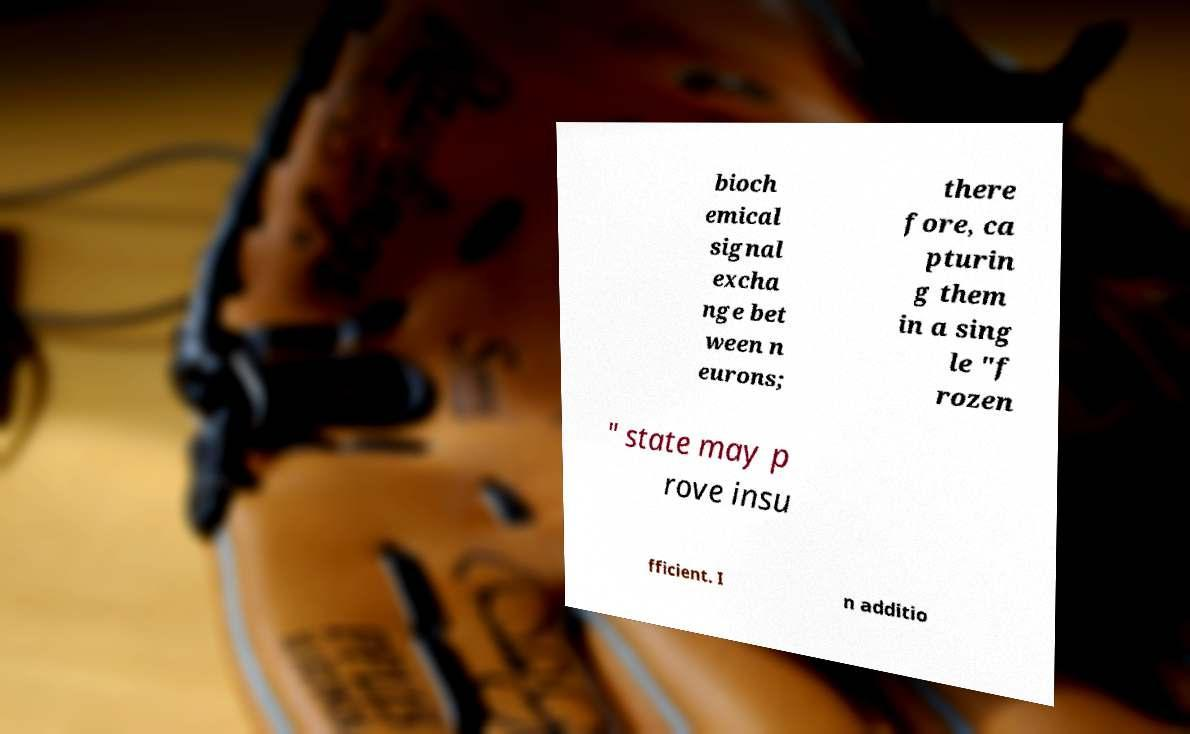Can you read and provide the text displayed in the image?This photo seems to have some interesting text. Can you extract and type it out for me? bioch emical signal excha nge bet ween n eurons; there fore, ca pturin g them in a sing le "f rozen " state may p rove insu fficient. I n additio 